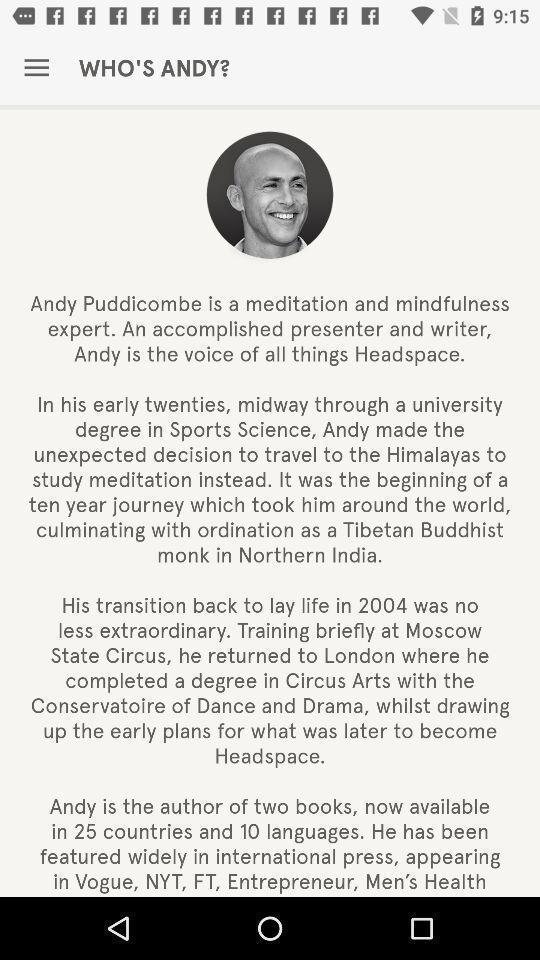Please provide a description for this image. Profile page of a learning app. 